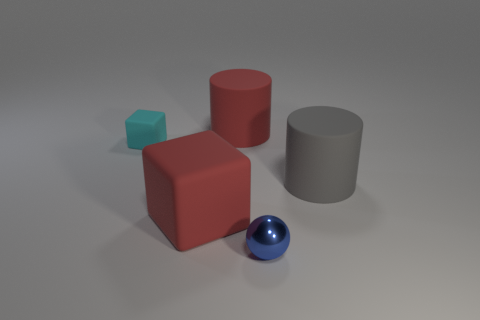Add 2 gray matte blocks. How many objects exist? 7 Subtract all cylinders. How many objects are left? 3 Add 5 small metal balls. How many small metal balls are left? 6 Add 4 big gray rubber things. How many big gray rubber things exist? 5 Subtract 0 green blocks. How many objects are left? 5 Subtract all blue metallic cylinders. Subtract all red blocks. How many objects are left? 4 